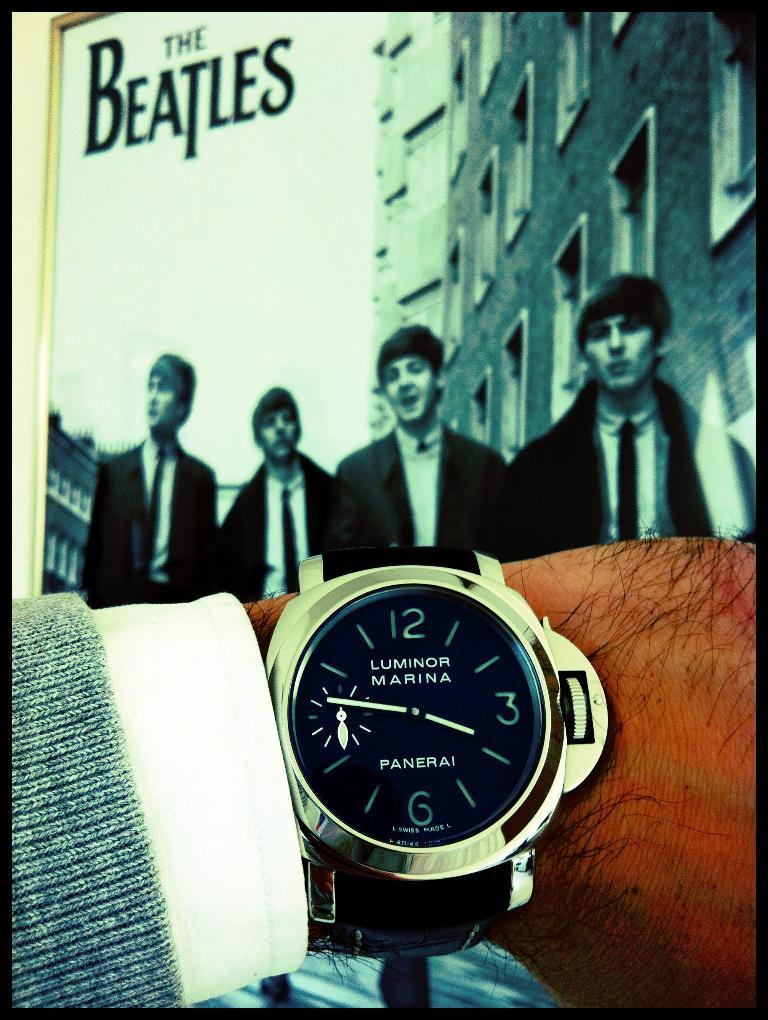<image>
Render a clear and concise summary of the photo. A Luminor Marina watch is being held up in front of a poster of the Beatles. 